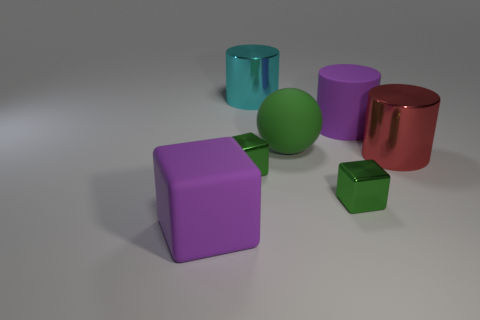Subtract all metallic cubes. How many cubes are left? 1 Add 3 rubber spheres. How many objects exist? 10 Subtract all cyan cylinders. How many cylinders are left? 2 Subtract 1 cylinders. How many cylinders are left? 2 Subtract all green cylinders. Subtract all yellow spheres. How many cylinders are left? 3 Subtract all cylinders. How many objects are left? 4 Subtract all brown spheres. How many green cubes are left? 2 Subtract all blue metal cylinders. Subtract all matte things. How many objects are left? 4 Add 3 tiny metal blocks. How many tiny metal blocks are left? 5 Add 7 green spheres. How many green spheres exist? 8 